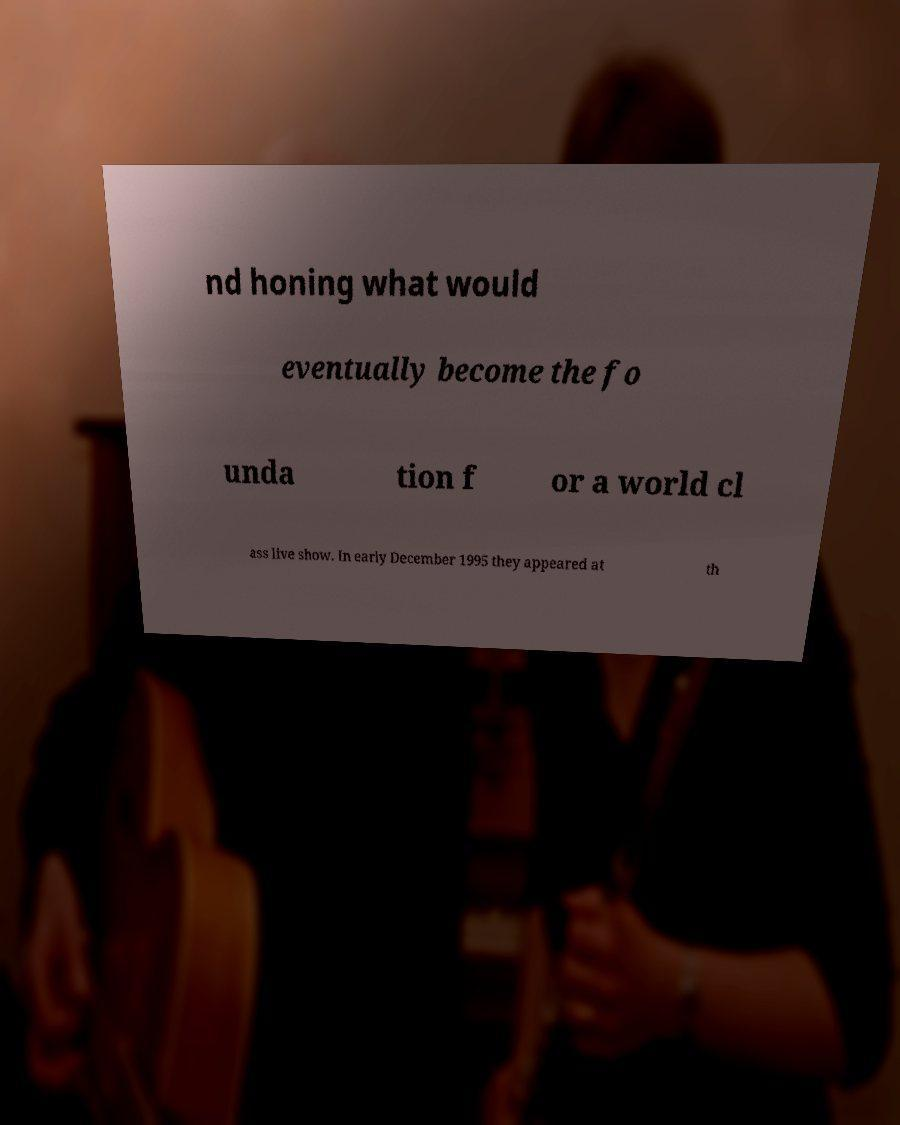I need the written content from this picture converted into text. Can you do that? nd honing what would eventually become the fo unda tion f or a world cl ass live show. In early December 1995 they appeared at th 